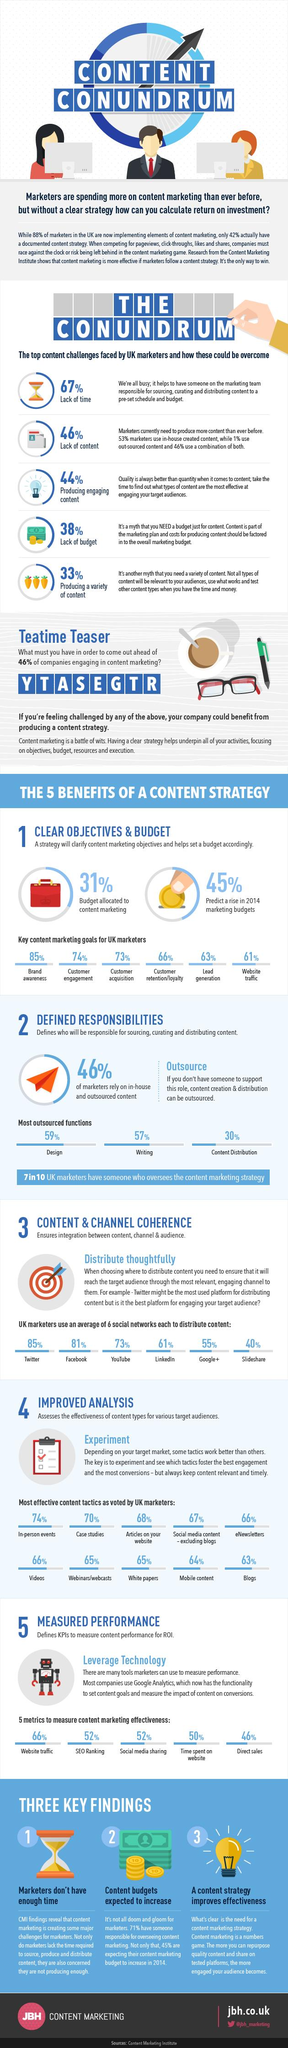List a handful of essential elements in this visual. According to a study in the UK, 68% of articles used for marketing purposes are effective in promoting products and services. The metric that is used the least to measure marketing effectiveness is direct sales. According to a study by Content Marketing Institute, 6 out of 10 UK marketers follow content marketing goals. Content distribution is the least outsourced among design, writing, and content distribution. According to the survey, customer engagement is the content marketing goal that is focused on the second highest percentage of value. 